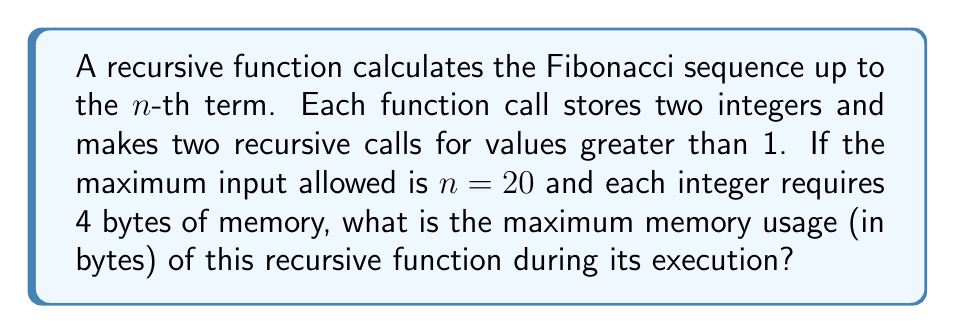Teach me how to tackle this problem. To solve this problem, we need to follow these steps:

1) First, let's consider the recursion tree for the Fibonacci function:
   $$F(n) = F(n-1) + F(n-2)$$

2) The maximum depth of this tree will be $n$, which is 20 in this case.

3) At each level of recursion, we store two integers (4 bytes each). So each function call uses 8 bytes.

4) The maximum number of simultaneous function calls occurs when we reach the deepest level of recursion. This happens along the leftmost branch of the recursion tree.

5) The number of simultaneous function calls is equal to the depth of the tree, which is 20.

6) Therefore, the maximum memory usage can be calculated as:
   $$\text{Max Memory} = \text{Depth} \times \text{Memory per call}$$
   $$\text{Max Memory} = 20 \times 8 \text{ bytes}$$
   $$\text{Max Memory} = 160 \text{ bytes}$$

Thus, the maximum memory usage of this recursive Fibonacci function for $n = 20$ is 160 bytes.
Answer: 160 bytes 